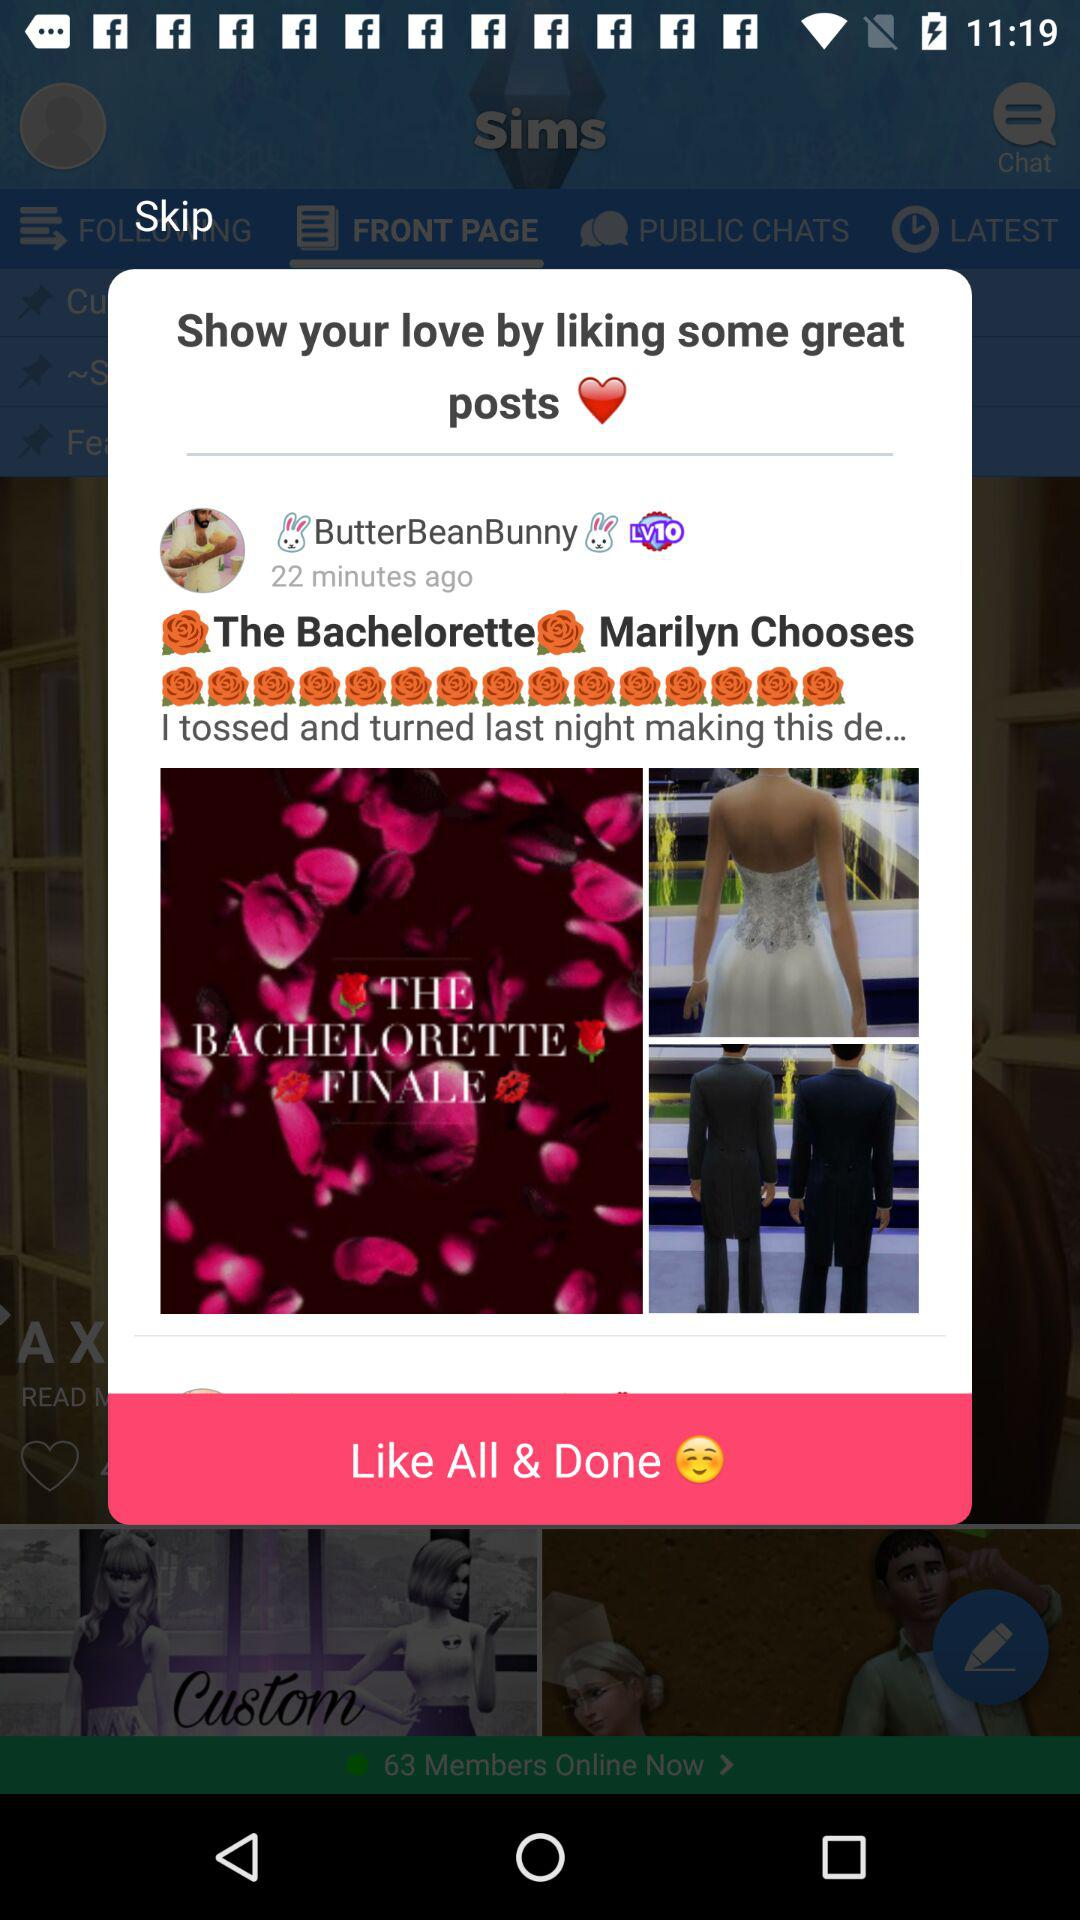What is the username? The username is "ButterBeanBunny". 